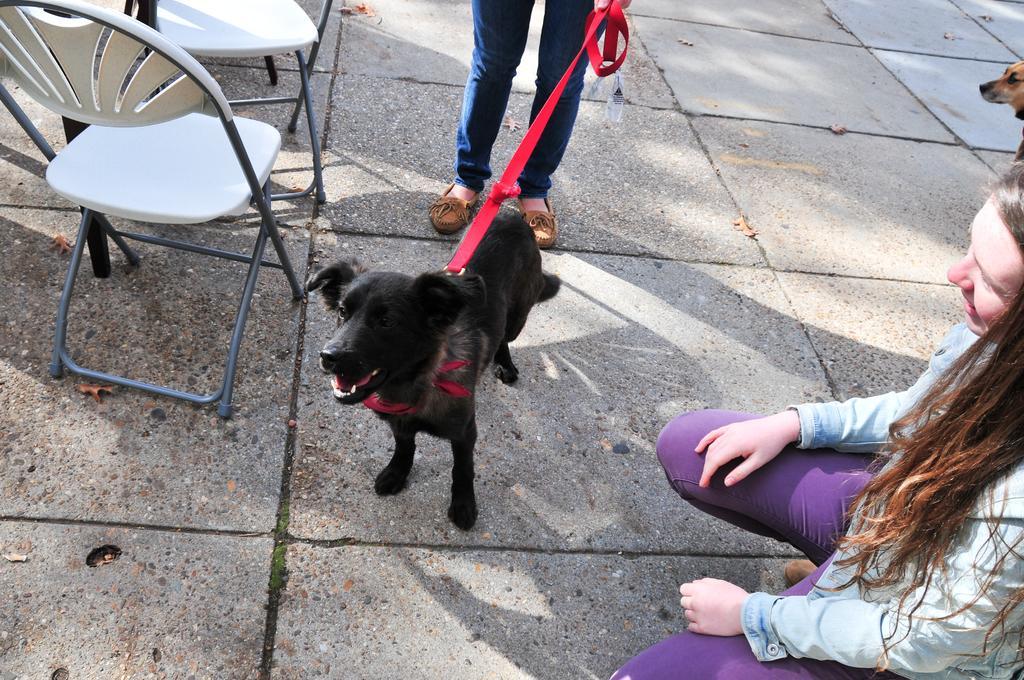In one or two sentences, can you explain what this image depicts? The picture is taken on the road where at the right corner one woman is sitting wearing purple pants and grey t-shirt, in front of her there is a dog which is tied with red belt and the belt is in a person's hand beside him there are chairs and table and at the very corner another dog is present. 